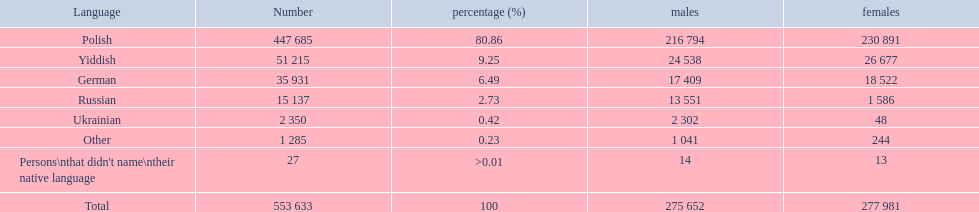What is the number of male and female individuals who speak german? 35931. Parse the full table. {'header': ['Language', 'Number', 'percentage (%)', 'males', 'females'], 'rows': [['Polish', '447 685', '80.86', '216 794', '230 891'], ['Yiddish', '51 215', '9.25', '24 538', '26 677'], ['German', '35 931', '6.49', '17 409', '18 522'], ['Russian', '15 137', '2.73', '13 551', '1 586'], ['Ukrainian', '2 350', '0.42', '2 302', '48'], ['Other', '1 285', '0.23', '1 041', '244'], ["Persons\\nthat didn't name\\ntheir native language", '27', '>0.01', '14', '13'], ['Total', '553 633', '100', '275 652', '277 981']]} 